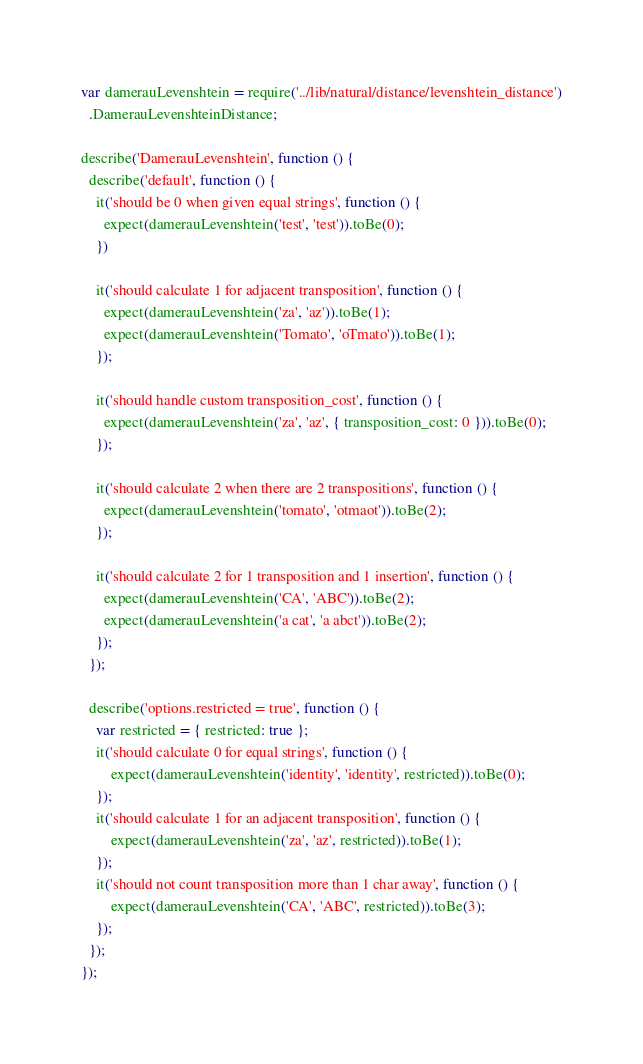Convert code to text. <code><loc_0><loc_0><loc_500><loc_500><_JavaScript_>var damerauLevenshtein = require('../lib/natural/distance/levenshtein_distance')
  .DamerauLevenshteinDistance;

describe('DamerauLevenshtein', function () {
  describe('default', function () {
    it('should be 0 when given equal strings', function () {
      expect(damerauLevenshtein('test', 'test')).toBe(0);
    })

    it('should calculate 1 for adjacent transposition', function () {
      expect(damerauLevenshtein('za', 'az')).toBe(1);
      expect(damerauLevenshtein('Tomato', 'oTmato')).toBe(1);
    });

    it('should handle custom transposition_cost', function () {
      expect(damerauLevenshtein('za', 'az', { transposition_cost: 0 })).toBe(0);
    });

    it('should calculate 2 when there are 2 transpositions', function () {
      expect(damerauLevenshtein('tomato', 'otmaot')).toBe(2);
    });

    it('should calculate 2 for 1 transposition and 1 insertion', function () {
      expect(damerauLevenshtein('CA', 'ABC')).toBe(2);
      expect(damerauLevenshtein('a cat', 'a abct')).toBe(2);
    });
  });

  describe('options.restricted = true', function () {
    var restricted = { restricted: true };
    it('should calculate 0 for equal strings', function () {
        expect(damerauLevenshtein('identity', 'identity', restricted)).toBe(0);
    });
    it('should calculate 1 for an adjacent transposition', function () {
        expect(damerauLevenshtein('za', 'az', restricted)).toBe(1);
    });
    it('should not count transposition more than 1 char away', function () {
        expect(damerauLevenshtein('CA', 'ABC', restricted)).toBe(3);
    });
  });
});
</code> 